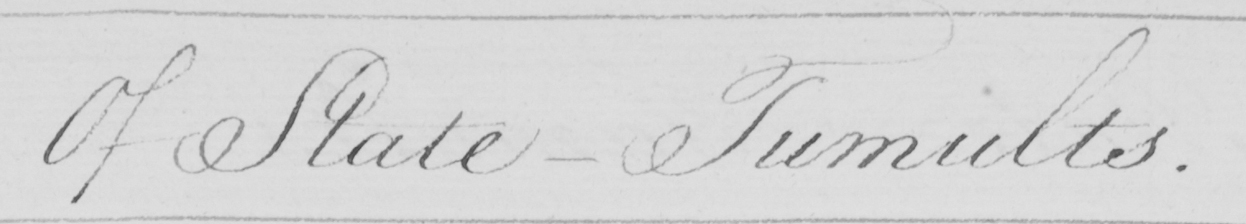Can you read and transcribe this handwriting? Of State-Tumults . 